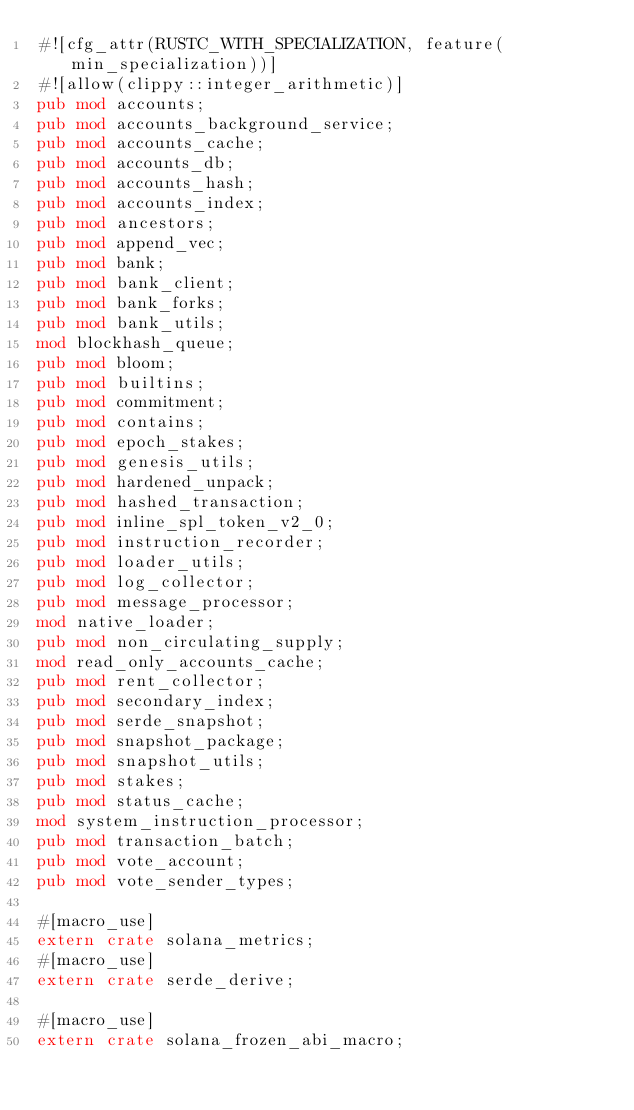<code> <loc_0><loc_0><loc_500><loc_500><_Rust_>#![cfg_attr(RUSTC_WITH_SPECIALIZATION, feature(min_specialization))]
#![allow(clippy::integer_arithmetic)]
pub mod accounts;
pub mod accounts_background_service;
pub mod accounts_cache;
pub mod accounts_db;
pub mod accounts_hash;
pub mod accounts_index;
pub mod ancestors;
pub mod append_vec;
pub mod bank;
pub mod bank_client;
pub mod bank_forks;
pub mod bank_utils;
mod blockhash_queue;
pub mod bloom;
pub mod builtins;
pub mod commitment;
pub mod contains;
pub mod epoch_stakes;
pub mod genesis_utils;
pub mod hardened_unpack;
pub mod hashed_transaction;
pub mod inline_spl_token_v2_0;
pub mod instruction_recorder;
pub mod loader_utils;
pub mod log_collector;
pub mod message_processor;
mod native_loader;
pub mod non_circulating_supply;
mod read_only_accounts_cache;
pub mod rent_collector;
pub mod secondary_index;
pub mod serde_snapshot;
pub mod snapshot_package;
pub mod snapshot_utils;
pub mod stakes;
pub mod status_cache;
mod system_instruction_processor;
pub mod transaction_batch;
pub mod vote_account;
pub mod vote_sender_types;

#[macro_use]
extern crate solana_metrics;
#[macro_use]
extern crate serde_derive;

#[macro_use]
extern crate solana_frozen_abi_macro;
</code> 